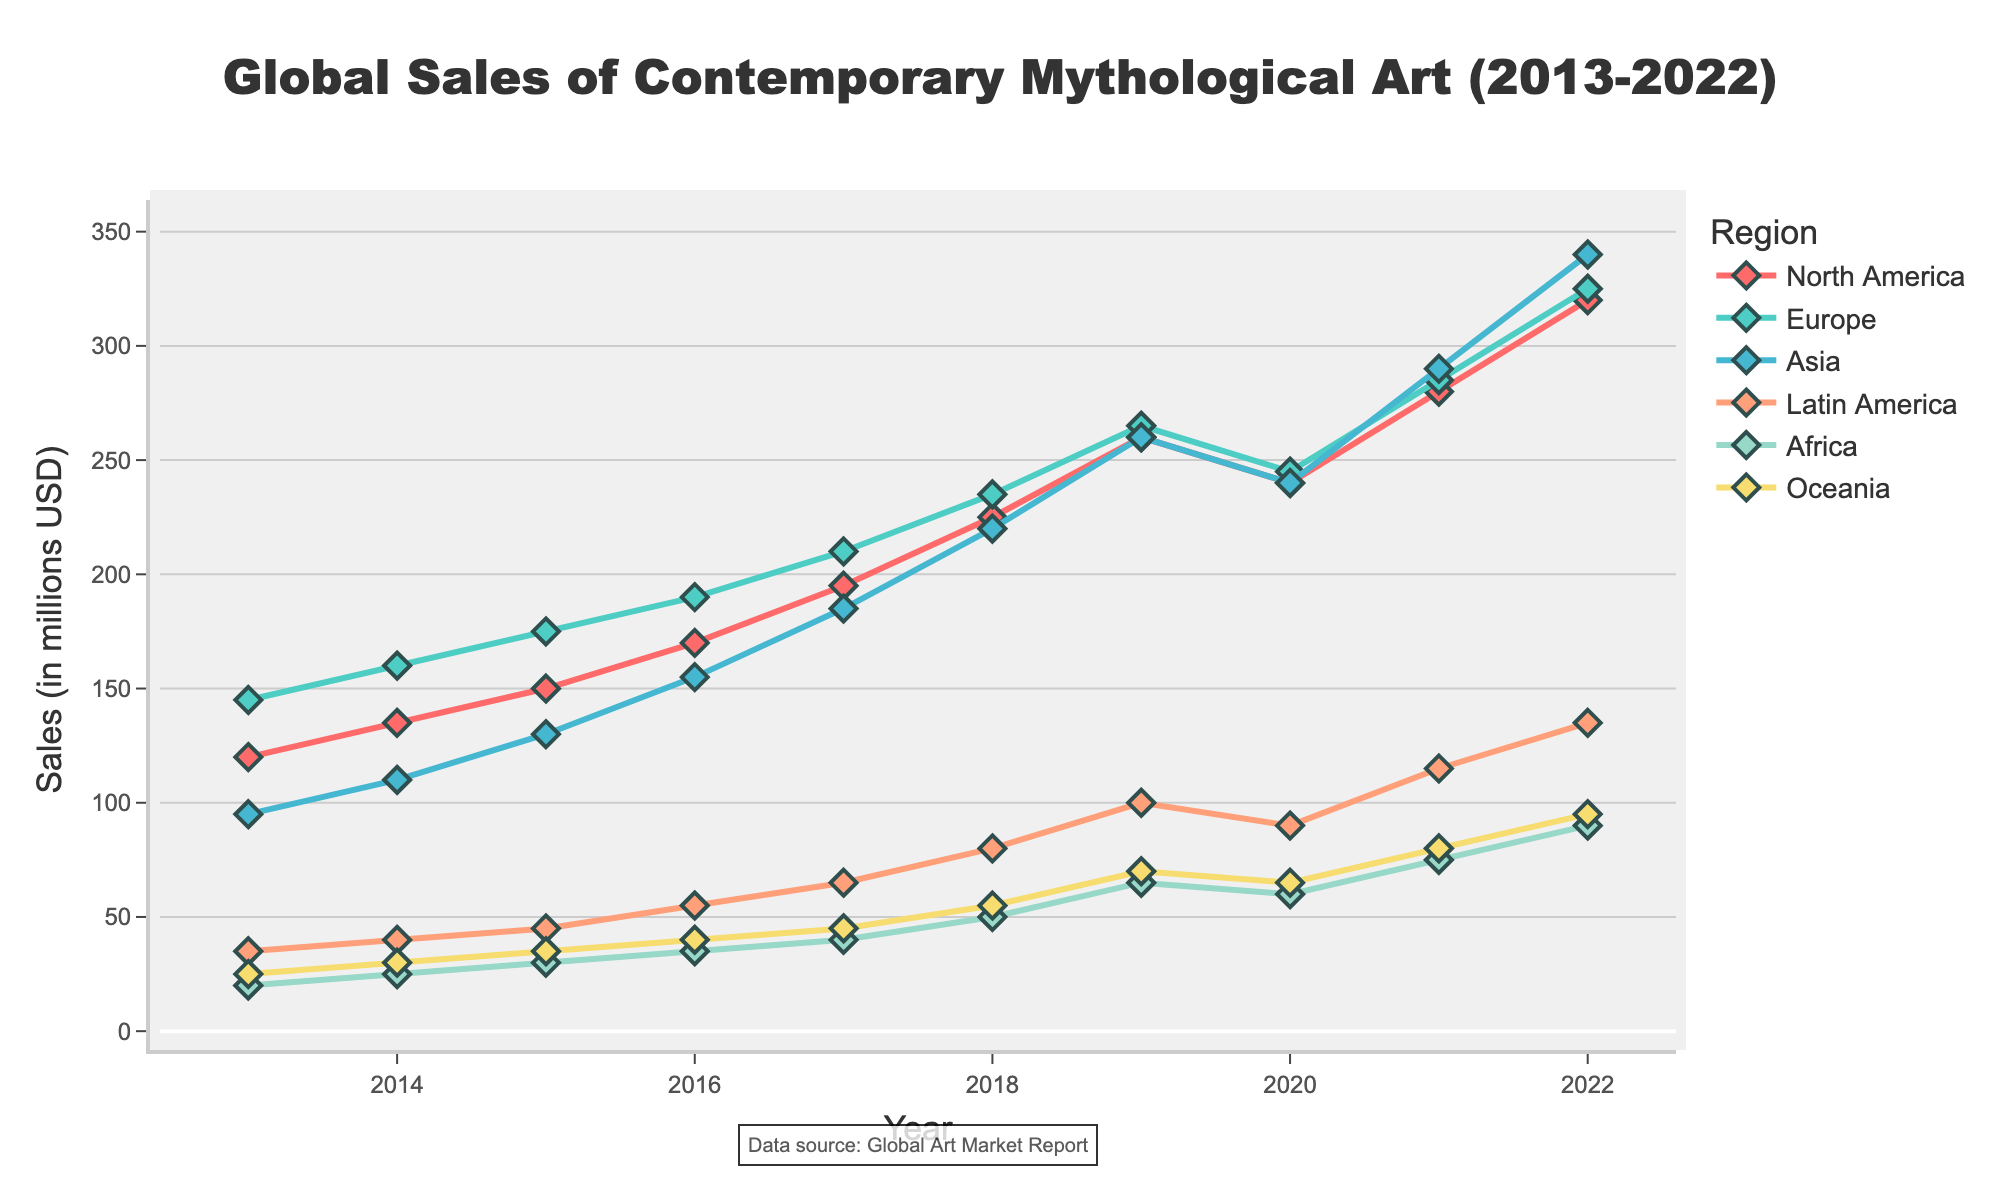Which region had the highest sales in 2019? In 2019, the sales figures were highest in Asia with 260 million USD, followed by North America with 260 million USD as well, Europe with 265 million USD, Latin America with 100 million USD, Africa with 65 million USD, and Oceania with 70 million USD. Among these, Europe had the highest with 265 million USD.
Answer: Europe What is the average sales value of North America over the decade? To find the average sales value, sum the sales values for North America from 2013 to 2022 (120 + 135 + 150 + 170 + 195 + 225 + 260 + 240 + 280 + 320) = 2095. Then divide by the number of years, which is 10. 2095 / 10 = 209.5 million USD.
Answer: 209.5 million USD Which region had the lowest sales in 2013 and how much did they sell? In 2013, the sales figures were 120 (North America), 145 (Europe), 95 (Asia), 35 (Latin America), 20 (Africa), and 25 (Oceania). Africa had the lowest sales with 20 million USD.
Answer: Africa with 20 million USD How did the sales trends for Latin America and Oceania compare from 2013 to 2022? From 2013 to 2022, both Latin America and Oceania show an upward trend in sales. Latin America's sales increased from 35 to 135 million USD, and Oceania's sales increased from 25 to 95 million USD. However, Latin America's sales growth was more significant than Oceania's.
Answer: Both increased, Latin America more significantly How much did the sales in Africa increase from 2013 to 2022? In 2013, Africa's sales were 20 million USD. In 2022, they reached 90 million USD. The increase is calculated as 90 - 20 = 70 million USD.
Answer: 70 million USD What was the peak sales value for Asia during the decade? By examining the sales values for Asia from 2013 to 2022, the highest value is seen in 2022 which is 340 million USD.
Answer: 340 million USD Between 2019 and 2020, which region experienced the largest drop in sales? Comparing sales figures for 2019 and 2020: North America (260 to 240), Europe (265 to 245), Asia (260 to 240), Latin America (100 to 90), Africa (65 to 60), and Oceania (70 to 65). Both North America and Asia experienced the largest drop of 20 million USD.
Answer: North America and Asia, 20 million USD What's the total sales for all regions combined in the year 2022? Sum the sales values for 2022 from all regions: 320 (North America) + 325 (Europe) + 340 (Asia) + 135 (Latin America) + 90 (Africa) + 95 (Oceania) = 1305 million USD.
Answer: 1305 million USD 